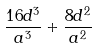Convert formula to latex. <formula><loc_0><loc_0><loc_500><loc_500>\frac { 1 6 d ^ { 3 } } { a ^ { 3 } } + \frac { 8 d ^ { 2 } } { a ^ { 2 } }</formula> 